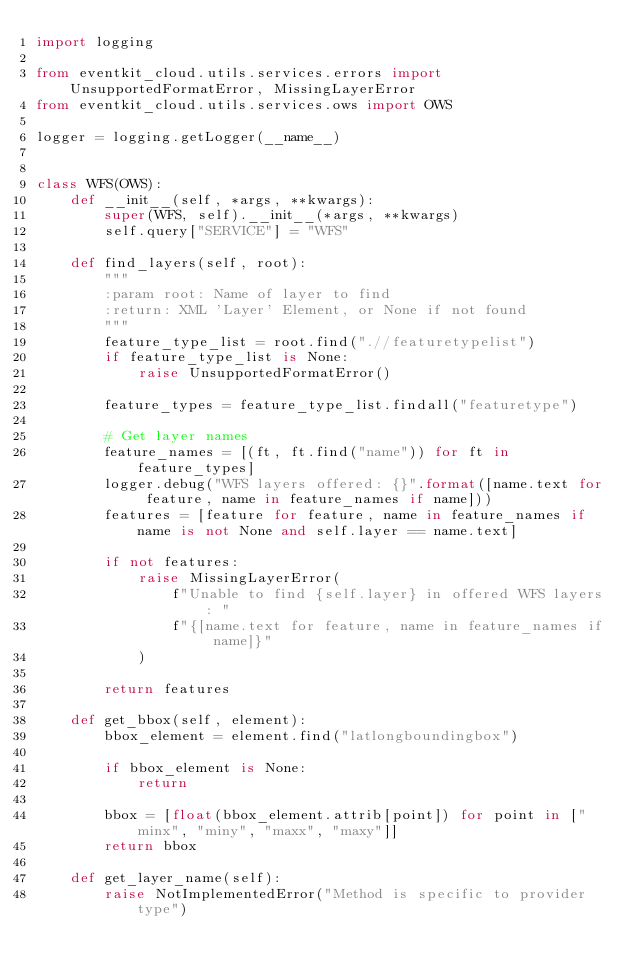Convert code to text. <code><loc_0><loc_0><loc_500><loc_500><_Python_>import logging

from eventkit_cloud.utils.services.errors import UnsupportedFormatError, MissingLayerError
from eventkit_cloud.utils.services.ows import OWS

logger = logging.getLogger(__name__)


class WFS(OWS):
    def __init__(self, *args, **kwargs):
        super(WFS, self).__init__(*args, **kwargs)
        self.query["SERVICE"] = "WFS"

    def find_layers(self, root):
        """
        :param root: Name of layer to find
        :return: XML 'Layer' Element, or None if not found
        """
        feature_type_list = root.find(".//featuretypelist")
        if feature_type_list is None:
            raise UnsupportedFormatError()

        feature_types = feature_type_list.findall("featuretype")

        # Get layer names
        feature_names = [(ft, ft.find("name")) for ft in feature_types]
        logger.debug("WFS layers offered: {}".format([name.text for feature, name in feature_names if name]))
        features = [feature for feature, name in feature_names if name is not None and self.layer == name.text]

        if not features:
            raise MissingLayerError(
                f"Unable to find {self.layer} in offered WFS layers: "
                f"{[name.text for feature, name in feature_names if name]}"
            )

        return features

    def get_bbox(self, element):
        bbox_element = element.find("latlongboundingbox")

        if bbox_element is None:
            return

        bbox = [float(bbox_element.attrib[point]) for point in ["minx", "miny", "maxx", "maxy"]]
        return bbox

    def get_layer_name(self):
        raise NotImplementedError("Method is specific to provider type")
</code> 